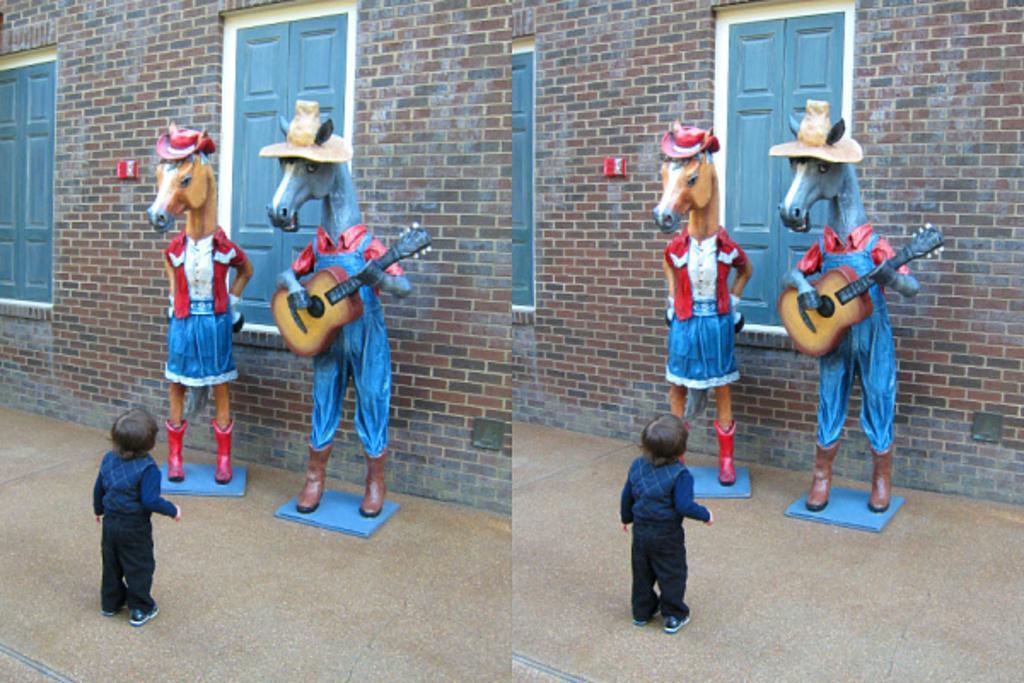Please provide a concise description of this image. In this image I can see there is a wall and on the wall there are the blue color windows and in front of the wall there is a statue seen and a child wearing a blue color jacket stand on the road. and right side I can see replica of left side image. 